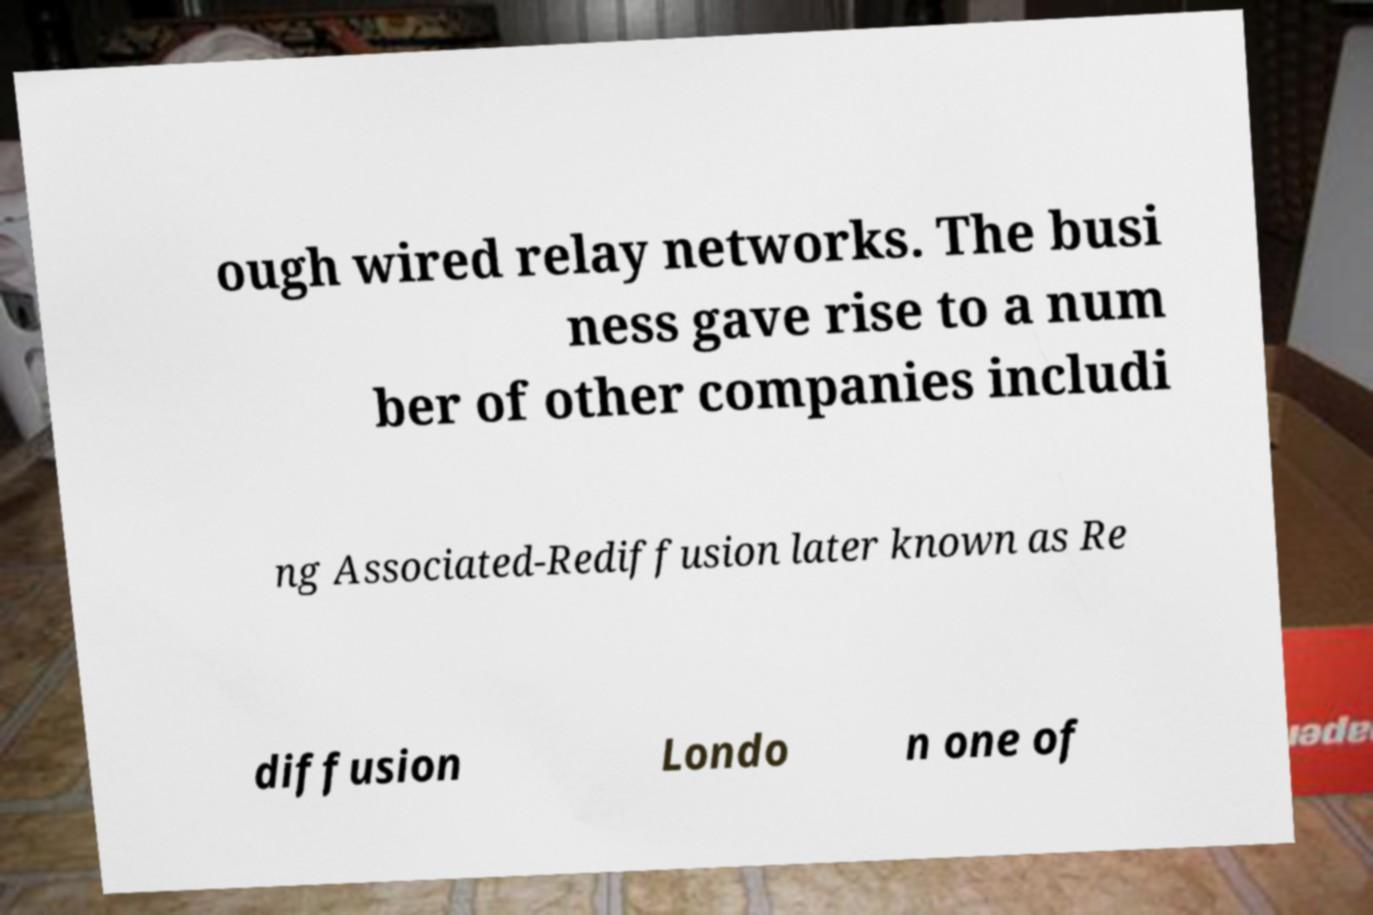Can you accurately transcribe the text from the provided image for me? ough wired relay networks. The busi ness gave rise to a num ber of other companies includi ng Associated-Rediffusion later known as Re diffusion Londo n one of 